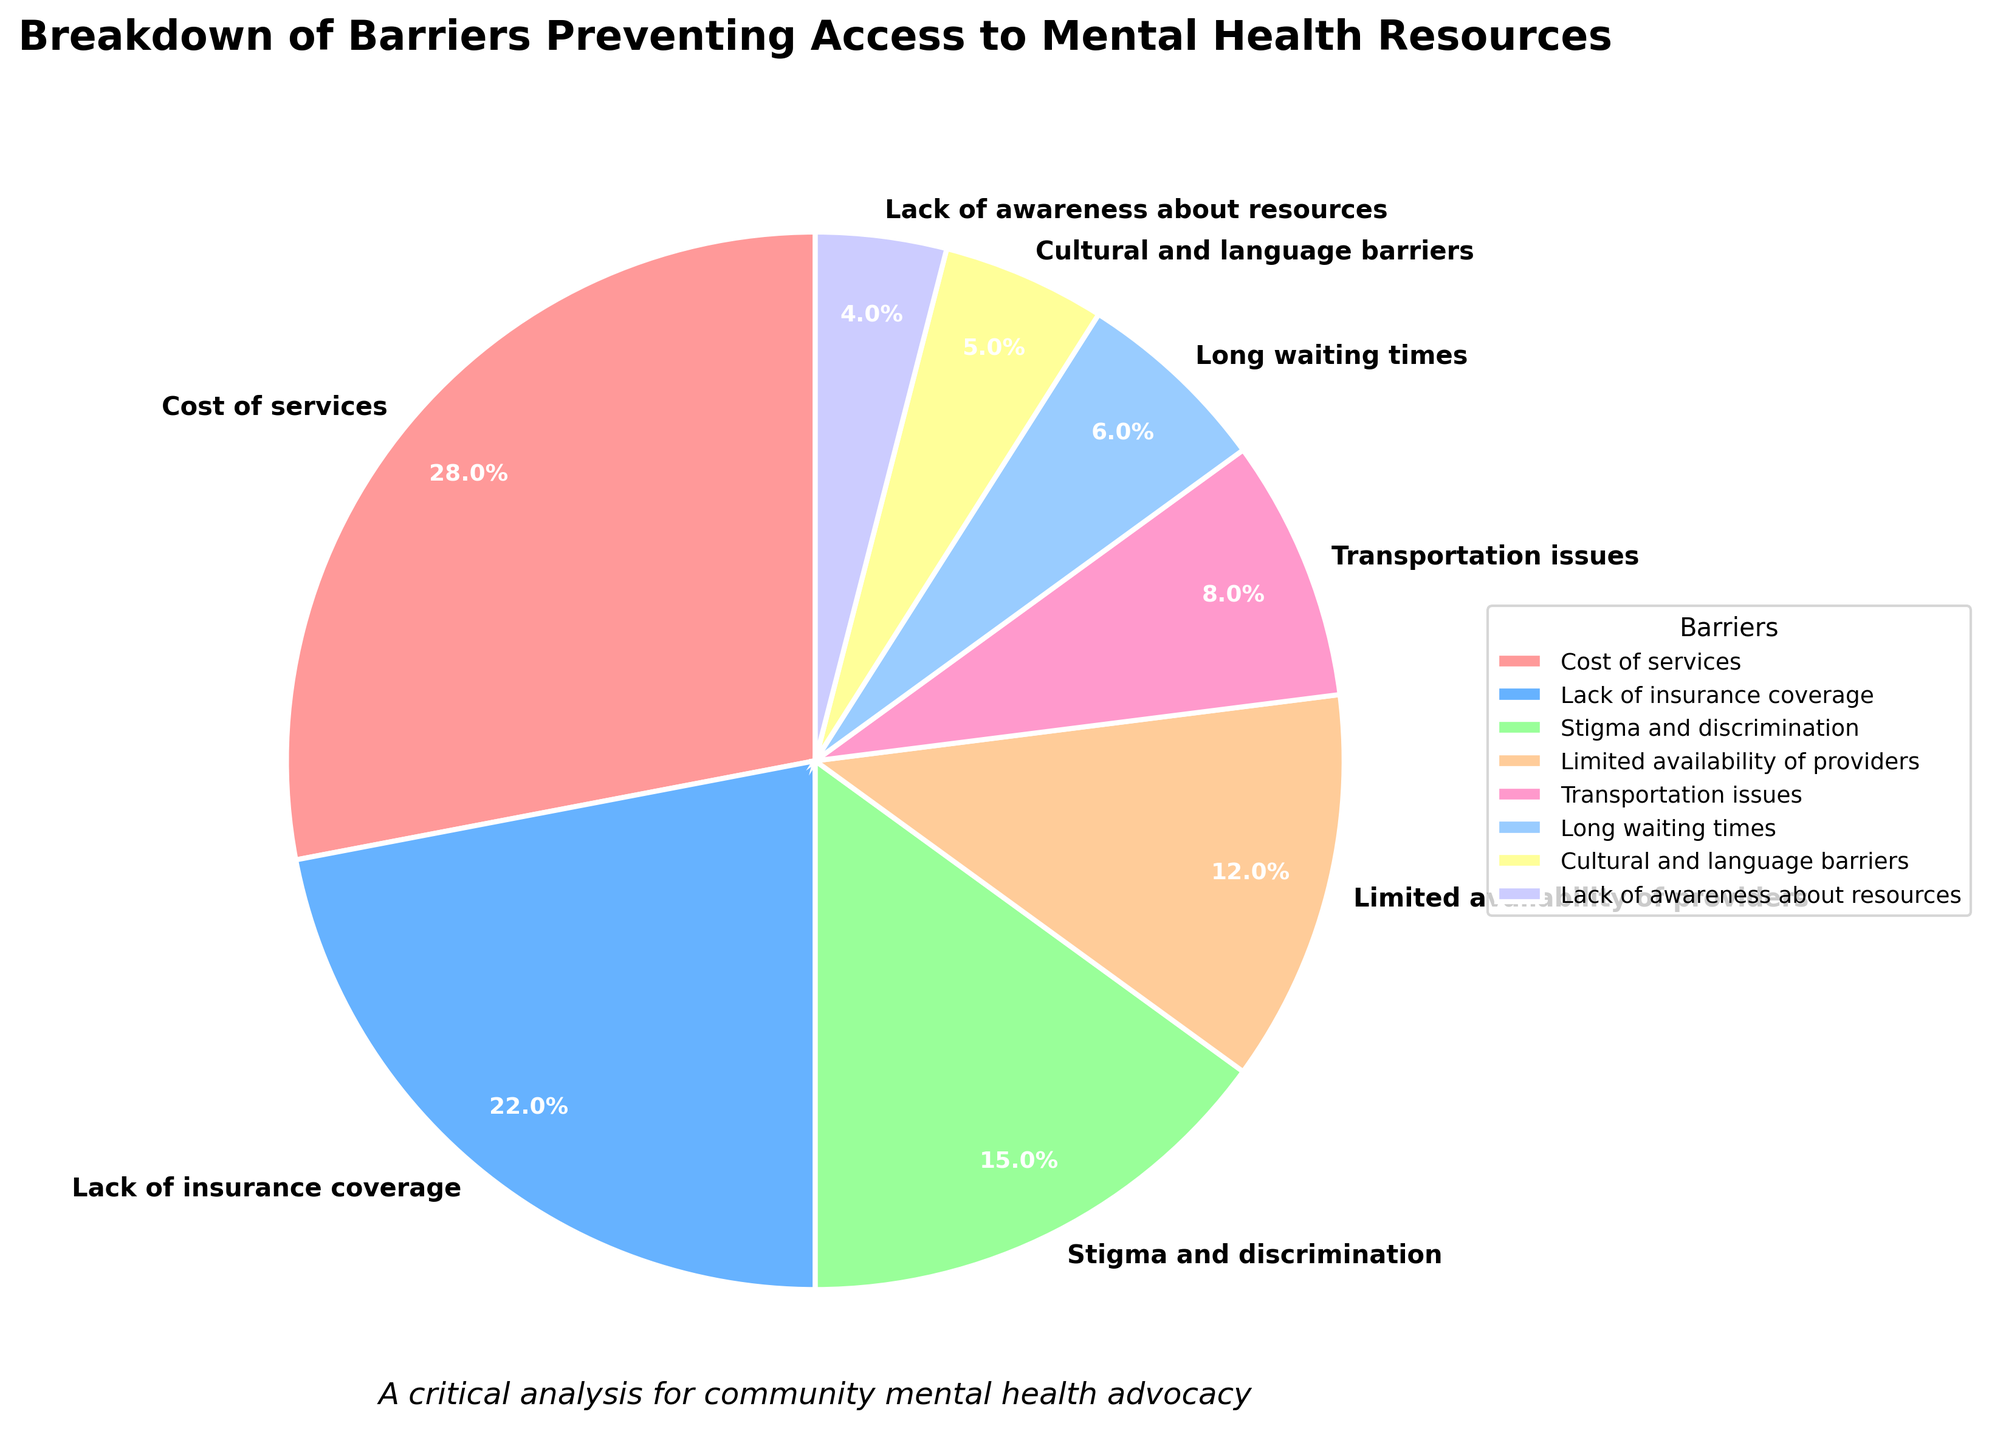What percentage of barriers combined result from "Cost of services" and "Lack of insurance coverage"? To find the combined percentage for "Cost of services" and "Lack of insurance coverage", add their individual percentages: 28% + 22% = 50%.
Answer: 50% Which barrier has the smallest percentage, and what is its value? From the pie chart, "Lack of awareness about resources" has the smallest percentage, represented by a 4% slice.
Answer: Lack of awareness about resources, 4% Is the percentage of barriers due to "Stigma and discrimination" greater than the sum of "Transportation issues" and "Long waiting times"? "Stigma and discrimination" is 15%. "Transportation issues" and "Long waiting times" sum up to 8% + 6% = 14%. 15% > 14%, so "Stigma and discrimination" is greater.
Answer: Yes What is the ratio of "Cost of services" to "Cultural and language barriers"? The percentage for "Cost of services" is 28%, and for "Cultural and language barriers" it is 5%. The ratio is 28:5 or simplifying it (divide both by 5): 5.6:1.
Answer: 5.6:1 Which barrier is represented by the blue color and what percentage does it occupy? The pie chart uses blue for "Lack of insurance coverage", which occupies 22%.
Answer: Lack of insurance coverage, 22% What is the difference in percentage between the largest and the smallest barriers? The largest barrier is "Cost of services" at 28%, and the smallest is "Lack of awareness about resources" at 4%. The difference is 28% - 4% = 24%.
Answer: 24% Among the barriers listed, how many have a percentage greater than 10%? The barriers greater than 10% are "Cost of services" (28%), "Lack of insurance coverage" (22%), "Stigma and discrimination" (15%), and "Limited availability of providers" (12%). So, there are four barriers greater than 10%.
Answer: 4 Is the combined percentage of "Limited availability of providers" and "Transportation issues" greater than 15%? "Limited availability of providers" is 12% and "Transportation issues" is 8%. Their combined percentage is 12% + 8% = 20%, which is greater than 15%.
Answer: Yes, 20% If you sum the percentages of all barriers except "Cost of services", what is the total? Summing the percentages of all barriers except "Cost of services" (28%): 22% + 15% + 12% + 8% + 6% + 5% + 4% = 72%.
Answer: 72% What is the average percentage of "Stigma and discrimination", "Transportation issues", and "Lack of awareness about resources"? The percentages are 15%, 8%, and 4%. Their sum is 15% + 8% + 4% = 27%. The average is 27% / 3 = 9%.
Answer: 9% 